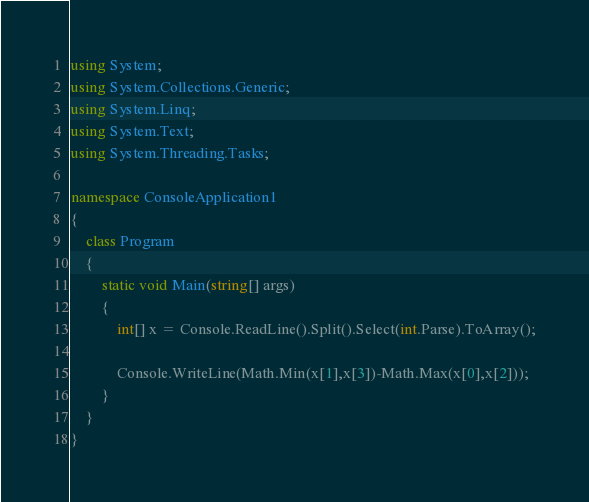Convert code to text. <code><loc_0><loc_0><loc_500><loc_500><_C#_>using System;
using System.Collections.Generic;
using System.Linq;
using System.Text;
using System.Threading.Tasks;

namespace ConsoleApplication1
{
    class Program
    {
        static void Main(string[] args)
        {
            int[] x = Console.ReadLine().Split().Select(int.Parse).ToArray();
            
            Console.WriteLine(Math.Min(x[1],x[3])-Math.Max(x[0],x[2]));
        }
    }
}</code> 